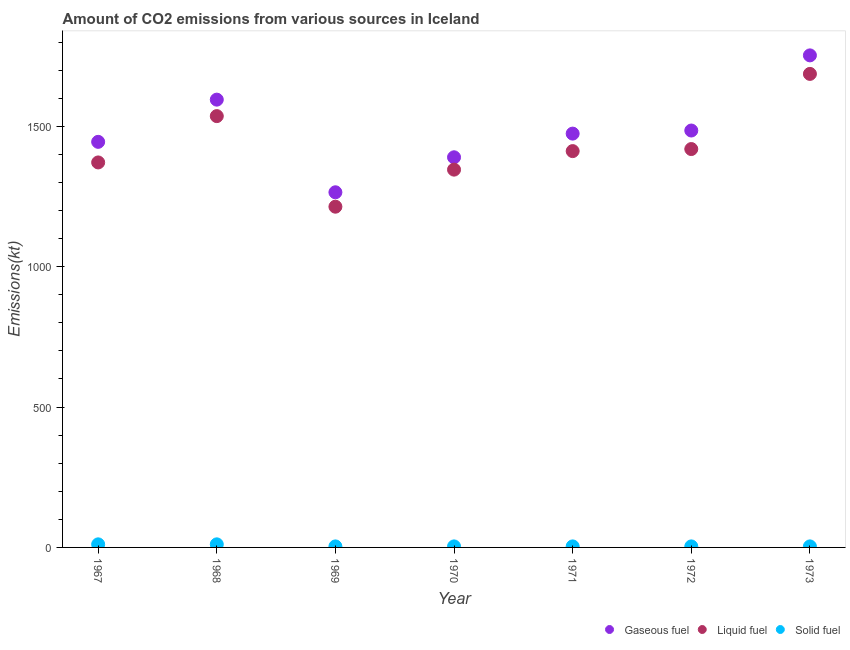What is the amount of co2 emissions from solid fuel in 1971?
Give a very brief answer. 3.67. Across all years, what is the maximum amount of co2 emissions from gaseous fuel?
Make the answer very short. 1752.83. Across all years, what is the minimum amount of co2 emissions from solid fuel?
Make the answer very short. 3.67. In which year was the amount of co2 emissions from liquid fuel minimum?
Offer a very short reply. 1969. What is the total amount of co2 emissions from gaseous fuel in the graph?
Provide a short and direct response. 1.04e+04. What is the difference between the amount of co2 emissions from liquid fuel in 1969 and the amount of co2 emissions from solid fuel in 1968?
Provide a succinct answer. 1202.78. What is the average amount of co2 emissions from gaseous fuel per year?
Give a very brief answer. 1486.71. In the year 1969, what is the difference between the amount of co2 emissions from liquid fuel and amount of co2 emissions from gaseous fuel?
Provide a succinct answer. -51.34. In how many years, is the amount of co2 emissions from gaseous fuel greater than 400 kt?
Provide a short and direct response. 7. What is the ratio of the amount of co2 emissions from gaseous fuel in 1967 to that in 1968?
Make the answer very short. 0.91. What is the difference between the highest and the lowest amount of co2 emissions from gaseous fuel?
Your answer should be very brief. 487.71. Is the amount of co2 emissions from gaseous fuel strictly greater than the amount of co2 emissions from liquid fuel over the years?
Your response must be concise. Yes. Is the amount of co2 emissions from solid fuel strictly less than the amount of co2 emissions from liquid fuel over the years?
Offer a very short reply. Yes. What is the difference between two consecutive major ticks on the Y-axis?
Give a very brief answer. 500. Does the graph contain any zero values?
Keep it short and to the point. No. Does the graph contain grids?
Give a very brief answer. No. How are the legend labels stacked?
Ensure brevity in your answer.  Horizontal. What is the title of the graph?
Give a very brief answer. Amount of CO2 emissions from various sources in Iceland. What is the label or title of the X-axis?
Provide a short and direct response. Year. What is the label or title of the Y-axis?
Your answer should be compact. Emissions(kt). What is the Emissions(kt) in Gaseous fuel in 1967?
Ensure brevity in your answer.  1444.8. What is the Emissions(kt) of Liquid fuel in 1967?
Keep it short and to the point. 1371.46. What is the Emissions(kt) of Solid fuel in 1967?
Give a very brief answer. 11. What is the Emissions(kt) of Gaseous fuel in 1968?
Your response must be concise. 1595.14. What is the Emissions(kt) of Liquid fuel in 1968?
Give a very brief answer. 1536.47. What is the Emissions(kt) of Solid fuel in 1968?
Provide a succinct answer. 11. What is the Emissions(kt) of Gaseous fuel in 1969?
Provide a succinct answer. 1265.12. What is the Emissions(kt) in Liquid fuel in 1969?
Ensure brevity in your answer.  1213.78. What is the Emissions(kt) of Solid fuel in 1969?
Offer a terse response. 3.67. What is the Emissions(kt) of Gaseous fuel in 1970?
Keep it short and to the point. 1389.79. What is the Emissions(kt) of Liquid fuel in 1970?
Keep it short and to the point. 1345.79. What is the Emissions(kt) in Solid fuel in 1970?
Give a very brief answer. 3.67. What is the Emissions(kt) in Gaseous fuel in 1971?
Your response must be concise. 1474.13. What is the Emissions(kt) in Liquid fuel in 1971?
Offer a terse response. 1411.8. What is the Emissions(kt) of Solid fuel in 1971?
Keep it short and to the point. 3.67. What is the Emissions(kt) in Gaseous fuel in 1972?
Make the answer very short. 1485.13. What is the Emissions(kt) of Liquid fuel in 1972?
Your answer should be compact. 1419.13. What is the Emissions(kt) of Solid fuel in 1972?
Offer a terse response. 3.67. What is the Emissions(kt) of Gaseous fuel in 1973?
Your response must be concise. 1752.83. What is the Emissions(kt) in Liquid fuel in 1973?
Give a very brief answer. 1686.82. What is the Emissions(kt) of Solid fuel in 1973?
Make the answer very short. 3.67. Across all years, what is the maximum Emissions(kt) of Gaseous fuel?
Offer a very short reply. 1752.83. Across all years, what is the maximum Emissions(kt) of Liquid fuel?
Give a very brief answer. 1686.82. Across all years, what is the maximum Emissions(kt) of Solid fuel?
Your answer should be compact. 11. Across all years, what is the minimum Emissions(kt) in Gaseous fuel?
Make the answer very short. 1265.12. Across all years, what is the minimum Emissions(kt) of Liquid fuel?
Offer a terse response. 1213.78. Across all years, what is the minimum Emissions(kt) in Solid fuel?
Keep it short and to the point. 3.67. What is the total Emissions(kt) in Gaseous fuel in the graph?
Ensure brevity in your answer.  1.04e+04. What is the total Emissions(kt) of Liquid fuel in the graph?
Give a very brief answer. 9985.24. What is the total Emissions(kt) of Solid fuel in the graph?
Provide a succinct answer. 40.34. What is the difference between the Emissions(kt) of Gaseous fuel in 1967 and that in 1968?
Your answer should be very brief. -150.35. What is the difference between the Emissions(kt) in Liquid fuel in 1967 and that in 1968?
Give a very brief answer. -165.01. What is the difference between the Emissions(kt) of Solid fuel in 1967 and that in 1968?
Ensure brevity in your answer.  0. What is the difference between the Emissions(kt) in Gaseous fuel in 1967 and that in 1969?
Provide a short and direct response. 179.68. What is the difference between the Emissions(kt) of Liquid fuel in 1967 and that in 1969?
Offer a very short reply. 157.68. What is the difference between the Emissions(kt) of Solid fuel in 1967 and that in 1969?
Provide a short and direct response. 7.33. What is the difference between the Emissions(kt) in Gaseous fuel in 1967 and that in 1970?
Your answer should be compact. 55.01. What is the difference between the Emissions(kt) in Liquid fuel in 1967 and that in 1970?
Offer a terse response. 25.67. What is the difference between the Emissions(kt) in Solid fuel in 1967 and that in 1970?
Keep it short and to the point. 7.33. What is the difference between the Emissions(kt) in Gaseous fuel in 1967 and that in 1971?
Offer a terse response. -29.34. What is the difference between the Emissions(kt) in Liquid fuel in 1967 and that in 1971?
Offer a terse response. -40.34. What is the difference between the Emissions(kt) in Solid fuel in 1967 and that in 1971?
Your answer should be compact. 7.33. What is the difference between the Emissions(kt) in Gaseous fuel in 1967 and that in 1972?
Provide a succinct answer. -40.34. What is the difference between the Emissions(kt) of Liquid fuel in 1967 and that in 1972?
Keep it short and to the point. -47.67. What is the difference between the Emissions(kt) of Solid fuel in 1967 and that in 1972?
Keep it short and to the point. 7.33. What is the difference between the Emissions(kt) of Gaseous fuel in 1967 and that in 1973?
Offer a very short reply. -308.03. What is the difference between the Emissions(kt) of Liquid fuel in 1967 and that in 1973?
Your answer should be compact. -315.36. What is the difference between the Emissions(kt) in Solid fuel in 1967 and that in 1973?
Your answer should be compact. 7.33. What is the difference between the Emissions(kt) in Gaseous fuel in 1968 and that in 1969?
Offer a terse response. 330.03. What is the difference between the Emissions(kt) of Liquid fuel in 1968 and that in 1969?
Offer a terse response. 322.7. What is the difference between the Emissions(kt) in Solid fuel in 1968 and that in 1969?
Your answer should be compact. 7.33. What is the difference between the Emissions(kt) in Gaseous fuel in 1968 and that in 1970?
Your answer should be very brief. 205.35. What is the difference between the Emissions(kt) in Liquid fuel in 1968 and that in 1970?
Your answer should be very brief. 190.68. What is the difference between the Emissions(kt) of Solid fuel in 1968 and that in 1970?
Provide a succinct answer. 7.33. What is the difference between the Emissions(kt) in Gaseous fuel in 1968 and that in 1971?
Your answer should be very brief. 121.01. What is the difference between the Emissions(kt) in Liquid fuel in 1968 and that in 1971?
Provide a succinct answer. 124.68. What is the difference between the Emissions(kt) in Solid fuel in 1968 and that in 1971?
Offer a terse response. 7.33. What is the difference between the Emissions(kt) in Gaseous fuel in 1968 and that in 1972?
Your answer should be compact. 110.01. What is the difference between the Emissions(kt) in Liquid fuel in 1968 and that in 1972?
Ensure brevity in your answer.  117.34. What is the difference between the Emissions(kt) in Solid fuel in 1968 and that in 1972?
Give a very brief answer. 7.33. What is the difference between the Emissions(kt) of Gaseous fuel in 1968 and that in 1973?
Your answer should be very brief. -157.68. What is the difference between the Emissions(kt) of Liquid fuel in 1968 and that in 1973?
Your response must be concise. -150.35. What is the difference between the Emissions(kt) of Solid fuel in 1968 and that in 1973?
Provide a succinct answer. 7.33. What is the difference between the Emissions(kt) of Gaseous fuel in 1969 and that in 1970?
Offer a terse response. -124.68. What is the difference between the Emissions(kt) in Liquid fuel in 1969 and that in 1970?
Make the answer very short. -132.01. What is the difference between the Emissions(kt) of Gaseous fuel in 1969 and that in 1971?
Provide a short and direct response. -209.02. What is the difference between the Emissions(kt) of Liquid fuel in 1969 and that in 1971?
Offer a very short reply. -198.02. What is the difference between the Emissions(kt) of Gaseous fuel in 1969 and that in 1972?
Offer a very short reply. -220.02. What is the difference between the Emissions(kt) of Liquid fuel in 1969 and that in 1972?
Make the answer very short. -205.35. What is the difference between the Emissions(kt) of Gaseous fuel in 1969 and that in 1973?
Your response must be concise. -487.71. What is the difference between the Emissions(kt) in Liquid fuel in 1969 and that in 1973?
Your response must be concise. -473.04. What is the difference between the Emissions(kt) in Solid fuel in 1969 and that in 1973?
Keep it short and to the point. 0. What is the difference between the Emissions(kt) in Gaseous fuel in 1970 and that in 1971?
Ensure brevity in your answer.  -84.34. What is the difference between the Emissions(kt) in Liquid fuel in 1970 and that in 1971?
Make the answer very short. -66.01. What is the difference between the Emissions(kt) in Gaseous fuel in 1970 and that in 1972?
Your response must be concise. -95.34. What is the difference between the Emissions(kt) in Liquid fuel in 1970 and that in 1972?
Ensure brevity in your answer.  -73.34. What is the difference between the Emissions(kt) of Solid fuel in 1970 and that in 1972?
Your answer should be very brief. 0. What is the difference between the Emissions(kt) of Gaseous fuel in 1970 and that in 1973?
Keep it short and to the point. -363.03. What is the difference between the Emissions(kt) in Liquid fuel in 1970 and that in 1973?
Give a very brief answer. -341.03. What is the difference between the Emissions(kt) in Gaseous fuel in 1971 and that in 1972?
Offer a very short reply. -11. What is the difference between the Emissions(kt) of Liquid fuel in 1971 and that in 1972?
Keep it short and to the point. -7.33. What is the difference between the Emissions(kt) of Gaseous fuel in 1971 and that in 1973?
Offer a very short reply. -278.69. What is the difference between the Emissions(kt) in Liquid fuel in 1971 and that in 1973?
Make the answer very short. -275.02. What is the difference between the Emissions(kt) of Solid fuel in 1971 and that in 1973?
Keep it short and to the point. 0. What is the difference between the Emissions(kt) of Gaseous fuel in 1972 and that in 1973?
Offer a very short reply. -267.69. What is the difference between the Emissions(kt) in Liquid fuel in 1972 and that in 1973?
Offer a very short reply. -267.69. What is the difference between the Emissions(kt) in Gaseous fuel in 1967 and the Emissions(kt) in Liquid fuel in 1968?
Make the answer very short. -91.67. What is the difference between the Emissions(kt) of Gaseous fuel in 1967 and the Emissions(kt) of Solid fuel in 1968?
Provide a short and direct response. 1433.8. What is the difference between the Emissions(kt) in Liquid fuel in 1967 and the Emissions(kt) in Solid fuel in 1968?
Your answer should be compact. 1360.46. What is the difference between the Emissions(kt) in Gaseous fuel in 1967 and the Emissions(kt) in Liquid fuel in 1969?
Provide a short and direct response. 231.02. What is the difference between the Emissions(kt) in Gaseous fuel in 1967 and the Emissions(kt) in Solid fuel in 1969?
Your answer should be very brief. 1441.13. What is the difference between the Emissions(kt) in Liquid fuel in 1967 and the Emissions(kt) in Solid fuel in 1969?
Your response must be concise. 1367.79. What is the difference between the Emissions(kt) in Gaseous fuel in 1967 and the Emissions(kt) in Liquid fuel in 1970?
Your answer should be very brief. 99.01. What is the difference between the Emissions(kt) of Gaseous fuel in 1967 and the Emissions(kt) of Solid fuel in 1970?
Provide a succinct answer. 1441.13. What is the difference between the Emissions(kt) in Liquid fuel in 1967 and the Emissions(kt) in Solid fuel in 1970?
Offer a terse response. 1367.79. What is the difference between the Emissions(kt) of Gaseous fuel in 1967 and the Emissions(kt) of Liquid fuel in 1971?
Provide a succinct answer. 33. What is the difference between the Emissions(kt) of Gaseous fuel in 1967 and the Emissions(kt) of Solid fuel in 1971?
Ensure brevity in your answer.  1441.13. What is the difference between the Emissions(kt) of Liquid fuel in 1967 and the Emissions(kt) of Solid fuel in 1971?
Your answer should be very brief. 1367.79. What is the difference between the Emissions(kt) of Gaseous fuel in 1967 and the Emissions(kt) of Liquid fuel in 1972?
Provide a short and direct response. 25.67. What is the difference between the Emissions(kt) of Gaseous fuel in 1967 and the Emissions(kt) of Solid fuel in 1972?
Keep it short and to the point. 1441.13. What is the difference between the Emissions(kt) of Liquid fuel in 1967 and the Emissions(kt) of Solid fuel in 1972?
Offer a very short reply. 1367.79. What is the difference between the Emissions(kt) in Gaseous fuel in 1967 and the Emissions(kt) in Liquid fuel in 1973?
Make the answer very short. -242.02. What is the difference between the Emissions(kt) of Gaseous fuel in 1967 and the Emissions(kt) of Solid fuel in 1973?
Your answer should be very brief. 1441.13. What is the difference between the Emissions(kt) of Liquid fuel in 1967 and the Emissions(kt) of Solid fuel in 1973?
Make the answer very short. 1367.79. What is the difference between the Emissions(kt) in Gaseous fuel in 1968 and the Emissions(kt) in Liquid fuel in 1969?
Provide a short and direct response. 381.37. What is the difference between the Emissions(kt) in Gaseous fuel in 1968 and the Emissions(kt) in Solid fuel in 1969?
Make the answer very short. 1591.48. What is the difference between the Emissions(kt) of Liquid fuel in 1968 and the Emissions(kt) of Solid fuel in 1969?
Keep it short and to the point. 1532.81. What is the difference between the Emissions(kt) of Gaseous fuel in 1968 and the Emissions(kt) of Liquid fuel in 1970?
Your answer should be compact. 249.36. What is the difference between the Emissions(kt) of Gaseous fuel in 1968 and the Emissions(kt) of Solid fuel in 1970?
Ensure brevity in your answer.  1591.48. What is the difference between the Emissions(kt) in Liquid fuel in 1968 and the Emissions(kt) in Solid fuel in 1970?
Your response must be concise. 1532.81. What is the difference between the Emissions(kt) in Gaseous fuel in 1968 and the Emissions(kt) in Liquid fuel in 1971?
Your response must be concise. 183.35. What is the difference between the Emissions(kt) of Gaseous fuel in 1968 and the Emissions(kt) of Solid fuel in 1971?
Offer a very short reply. 1591.48. What is the difference between the Emissions(kt) in Liquid fuel in 1968 and the Emissions(kt) in Solid fuel in 1971?
Keep it short and to the point. 1532.81. What is the difference between the Emissions(kt) of Gaseous fuel in 1968 and the Emissions(kt) of Liquid fuel in 1972?
Your answer should be compact. 176.02. What is the difference between the Emissions(kt) in Gaseous fuel in 1968 and the Emissions(kt) in Solid fuel in 1972?
Offer a terse response. 1591.48. What is the difference between the Emissions(kt) of Liquid fuel in 1968 and the Emissions(kt) of Solid fuel in 1972?
Keep it short and to the point. 1532.81. What is the difference between the Emissions(kt) of Gaseous fuel in 1968 and the Emissions(kt) of Liquid fuel in 1973?
Your answer should be compact. -91.67. What is the difference between the Emissions(kt) of Gaseous fuel in 1968 and the Emissions(kt) of Solid fuel in 1973?
Make the answer very short. 1591.48. What is the difference between the Emissions(kt) of Liquid fuel in 1968 and the Emissions(kt) of Solid fuel in 1973?
Your answer should be compact. 1532.81. What is the difference between the Emissions(kt) in Gaseous fuel in 1969 and the Emissions(kt) in Liquid fuel in 1970?
Offer a very short reply. -80.67. What is the difference between the Emissions(kt) of Gaseous fuel in 1969 and the Emissions(kt) of Solid fuel in 1970?
Offer a terse response. 1261.45. What is the difference between the Emissions(kt) in Liquid fuel in 1969 and the Emissions(kt) in Solid fuel in 1970?
Offer a very short reply. 1210.11. What is the difference between the Emissions(kt) of Gaseous fuel in 1969 and the Emissions(kt) of Liquid fuel in 1971?
Provide a succinct answer. -146.68. What is the difference between the Emissions(kt) of Gaseous fuel in 1969 and the Emissions(kt) of Solid fuel in 1971?
Provide a short and direct response. 1261.45. What is the difference between the Emissions(kt) in Liquid fuel in 1969 and the Emissions(kt) in Solid fuel in 1971?
Offer a very short reply. 1210.11. What is the difference between the Emissions(kt) in Gaseous fuel in 1969 and the Emissions(kt) in Liquid fuel in 1972?
Your response must be concise. -154.01. What is the difference between the Emissions(kt) in Gaseous fuel in 1969 and the Emissions(kt) in Solid fuel in 1972?
Give a very brief answer. 1261.45. What is the difference between the Emissions(kt) of Liquid fuel in 1969 and the Emissions(kt) of Solid fuel in 1972?
Your answer should be compact. 1210.11. What is the difference between the Emissions(kt) of Gaseous fuel in 1969 and the Emissions(kt) of Liquid fuel in 1973?
Your answer should be compact. -421.7. What is the difference between the Emissions(kt) of Gaseous fuel in 1969 and the Emissions(kt) of Solid fuel in 1973?
Offer a terse response. 1261.45. What is the difference between the Emissions(kt) of Liquid fuel in 1969 and the Emissions(kt) of Solid fuel in 1973?
Make the answer very short. 1210.11. What is the difference between the Emissions(kt) in Gaseous fuel in 1970 and the Emissions(kt) in Liquid fuel in 1971?
Your answer should be very brief. -22. What is the difference between the Emissions(kt) in Gaseous fuel in 1970 and the Emissions(kt) in Solid fuel in 1971?
Offer a terse response. 1386.13. What is the difference between the Emissions(kt) in Liquid fuel in 1970 and the Emissions(kt) in Solid fuel in 1971?
Your answer should be very brief. 1342.12. What is the difference between the Emissions(kt) of Gaseous fuel in 1970 and the Emissions(kt) of Liquid fuel in 1972?
Your answer should be very brief. -29.34. What is the difference between the Emissions(kt) of Gaseous fuel in 1970 and the Emissions(kt) of Solid fuel in 1972?
Ensure brevity in your answer.  1386.13. What is the difference between the Emissions(kt) of Liquid fuel in 1970 and the Emissions(kt) of Solid fuel in 1972?
Your answer should be compact. 1342.12. What is the difference between the Emissions(kt) in Gaseous fuel in 1970 and the Emissions(kt) in Liquid fuel in 1973?
Make the answer very short. -297.03. What is the difference between the Emissions(kt) in Gaseous fuel in 1970 and the Emissions(kt) in Solid fuel in 1973?
Make the answer very short. 1386.13. What is the difference between the Emissions(kt) of Liquid fuel in 1970 and the Emissions(kt) of Solid fuel in 1973?
Make the answer very short. 1342.12. What is the difference between the Emissions(kt) of Gaseous fuel in 1971 and the Emissions(kt) of Liquid fuel in 1972?
Offer a terse response. 55.01. What is the difference between the Emissions(kt) in Gaseous fuel in 1971 and the Emissions(kt) in Solid fuel in 1972?
Provide a short and direct response. 1470.47. What is the difference between the Emissions(kt) in Liquid fuel in 1971 and the Emissions(kt) in Solid fuel in 1972?
Your answer should be very brief. 1408.13. What is the difference between the Emissions(kt) of Gaseous fuel in 1971 and the Emissions(kt) of Liquid fuel in 1973?
Offer a terse response. -212.69. What is the difference between the Emissions(kt) in Gaseous fuel in 1971 and the Emissions(kt) in Solid fuel in 1973?
Your answer should be very brief. 1470.47. What is the difference between the Emissions(kt) in Liquid fuel in 1971 and the Emissions(kt) in Solid fuel in 1973?
Provide a succinct answer. 1408.13. What is the difference between the Emissions(kt) of Gaseous fuel in 1972 and the Emissions(kt) of Liquid fuel in 1973?
Your response must be concise. -201.69. What is the difference between the Emissions(kt) in Gaseous fuel in 1972 and the Emissions(kt) in Solid fuel in 1973?
Make the answer very short. 1481.47. What is the difference between the Emissions(kt) in Liquid fuel in 1972 and the Emissions(kt) in Solid fuel in 1973?
Your answer should be compact. 1415.46. What is the average Emissions(kt) in Gaseous fuel per year?
Ensure brevity in your answer.  1486.71. What is the average Emissions(kt) in Liquid fuel per year?
Your answer should be very brief. 1426.46. What is the average Emissions(kt) in Solid fuel per year?
Your answer should be very brief. 5.76. In the year 1967, what is the difference between the Emissions(kt) in Gaseous fuel and Emissions(kt) in Liquid fuel?
Offer a terse response. 73.34. In the year 1967, what is the difference between the Emissions(kt) in Gaseous fuel and Emissions(kt) in Solid fuel?
Your response must be concise. 1433.8. In the year 1967, what is the difference between the Emissions(kt) in Liquid fuel and Emissions(kt) in Solid fuel?
Give a very brief answer. 1360.46. In the year 1968, what is the difference between the Emissions(kt) in Gaseous fuel and Emissions(kt) in Liquid fuel?
Keep it short and to the point. 58.67. In the year 1968, what is the difference between the Emissions(kt) in Gaseous fuel and Emissions(kt) in Solid fuel?
Ensure brevity in your answer.  1584.14. In the year 1968, what is the difference between the Emissions(kt) in Liquid fuel and Emissions(kt) in Solid fuel?
Make the answer very short. 1525.47. In the year 1969, what is the difference between the Emissions(kt) of Gaseous fuel and Emissions(kt) of Liquid fuel?
Your response must be concise. 51.34. In the year 1969, what is the difference between the Emissions(kt) in Gaseous fuel and Emissions(kt) in Solid fuel?
Give a very brief answer. 1261.45. In the year 1969, what is the difference between the Emissions(kt) in Liquid fuel and Emissions(kt) in Solid fuel?
Provide a succinct answer. 1210.11. In the year 1970, what is the difference between the Emissions(kt) of Gaseous fuel and Emissions(kt) of Liquid fuel?
Ensure brevity in your answer.  44. In the year 1970, what is the difference between the Emissions(kt) of Gaseous fuel and Emissions(kt) of Solid fuel?
Provide a short and direct response. 1386.13. In the year 1970, what is the difference between the Emissions(kt) of Liquid fuel and Emissions(kt) of Solid fuel?
Your answer should be very brief. 1342.12. In the year 1971, what is the difference between the Emissions(kt) in Gaseous fuel and Emissions(kt) in Liquid fuel?
Your response must be concise. 62.34. In the year 1971, what is the difference between the Emissions(kt) of Gaseous fuel and Emissions(kt) of Solid fuel?
Make the answer very short. 1470.47. In the year 1971, what is the difference between the Emissions(kt) in Liquid fuel and Emissions(kt) in Solid fuel?
Give a very brief answer. 1408.13. In the year 1972, what is the difference between the Emissions(kt) of Gaseous fuel and Emissions(kt) of Liquid fuel?
Provide a succinct answer. 66.01. In the year 1972, what is the difference between the Emissions(kt) in Gaseous fuel and Emissions(kt) in Solid fuel?
Your response must be concise. 1481.47. In the year 1972, what is the difference between the Emissions(kt) in Liquid fuel and Emissions(kt) in Solid fuel?
Your answer should be compact. 1415.46. In the year 1973, what is the difference between the Emissions(kt) in Gaseous fuel and Emissions(kt) in Liquid fuel?
Keep it short and to the point. 66.01. In the year 1973, what is the difference between the Emissions(kt) of Gaseous fuel and Emissions(kt) of Solid fuel?
Offer a terse response. 1749.16. In the year 1973, what is the difference between the Emissions(kt) in Liquid fuel and Emissions(kt) in Solid fuel?
Your answer should be compact. 1683.15. What is the ratio of the Emissions(kt) in Gaseous fuel in 1967 to that in 1968?
Give a very brief answer. 0.91. What is the ratio of the Emissions(kt) in Liquid fuel in 1967 to that in 1968?
Keep it short and to the point. 0.89. What is the ratio of the Emissions(kt) of Solid fuel in 1967 to that in 1968?
Make the answer very short. 1. What is the ratio of the Emissions(kt) of Gaseous fuel in 1967 to that in 1969?
Make the answer very short. 1.14. What is the ratio of the Emissions(kt) of Liquid fuel in 1967 to that in 1969?
Provide a short and direct response. 1.13. What is the ratio of the Emissions(kt) of Solid fuel in 1967 to that in 1969?
Your response must be concise. 3. What is the ratio of the Emissions(kt) of Gaseous fuel in 1967 to that in 1970?
Make the answer very short. 1.04. What is the ratio of the Emissions(kt) in Liquid fuel in 1967 to that in 1970?
Your answer should be very brief. 1.02. What is the ratio of the Emissions(kt) of Solid fuel in 1967 to that in 1970?
Provide a short and direct response. 3. What is the ratio of the Emissions(kt) in Gaseous fuel in 1967 to that in 1971?
Provide a succinct answer. 0.98. What is the ratio of the Emissions(kt) in Liquid fuel in 1967 to that in 1971?
Ensure brevity in your answer.  0.97. What is the ratio of the Emissions(kt) of Gaseous fuel in 1967 to that in 1972?
Provide a short and direct response. 0.97. What is the ratio of the Emissions(kt) in Liquid fuel in 1967 to that in 1972?
Provide a short and direct response. 0.97. What is the ratio of the Emissions(kt) of Gaseous fuel in 1967 to that in 1973?
Offer a very short reply. 0.82. What is the ratio of the Emissions(kt) of Liquid fuel in 1967 to that in 1973?
Give a very brief answer. 0.81. What is the ratio of the Emissions(kt) of Gaseous fuel in 1968 to that in 1969?
Your response must be concise. 1.26. What is the ratio of the Emissions(kt) of Liquid fuel in 1968 to that in 1969?
Your response must be concise. 1.27. What is the ratio of the Emissions(kt) of Solid fuel in 1968 to that in 1969?
Make the answer very short. 3. What is the ratio of the Emissions(kt) of Gaseous fuel in 1968 to that in 1970?
Offer a very short reply. 1.15. What is the ratio of the Emissions(kt) of Liquid fuel in 1968 to that in 1970?
Keep it short and to the point. 1.14. What is the ratio of the Emissions(kt) of Solid fuel in 1968 to that in 1970?
Provide a succinct answer. 3. What is the ratio of the Emissions(kt) in Gaseous fuel in 1968 to that in 1971?
Your answer should be very brief. 1.08. What is the ratio of the Emissions(kt) in Liquid fuel in 1968 to that in 1971?
Ensure brevity in your answer.  1.09. What is the ratio of the Emissions(kt) in Gaseous fuel in 1968 to that in 1972?
Ensure brevity in your answer.  1.07. What is the ratio of the Emissions(kt) in Liquid fuel in 1968 to that in 1972?
Make the answer very short. 1.08. What is the ratio of the Emissions(kt) of Gaseous fuel in 1968 to that in 1973?
Make the answer very short. 0.91. What is the ratio of the Emissions(kt) of Liquid fuel in 1968 to that in 1973?
Provide a succinct answer. 0.91. What is the ratio of the Emissions(kt) in Solid fuel in 1968 to that in 1973?
Give a very brief answer. 3. What is the ratio of the Emissions(kt) of Gaseous fuel in 1969 to that in 1970?
Give a very brief answer. 0.91. What is the ratio of the Emissions(kt) in Liquid fuel in 1969 to that in 1970?
Make the answer very short. 0.9. What is the ratio of the Emissions(kt) of Solid fuel in 1969 to that in 1970?
Give a very brief answer. 1. What is the ratio of the Emissions(kt) in Gaseous fuel in 1969 to that in 1971?
Your answer should be very brief. 0.86. What is the ratio of the Emissions(kt) of Liquid fuel in 1969 to that in 1971?
Keep it short and to the point. 0.86. What is the ratio of the Emissions(kt) in Solid fuel in 1969 to that in 1971?
Ensure brevity in your answer.  1. What is the ratio of the Emissions(kt) in Gaseous fuel in 1969 to that in 1972?
Provide a short and direct response. 0.85. What is the ratio of the Emissions(kt) in Liquid fuel in 1969 to that in 1972?
Keep it short and to the point. 0.86. What is the ratio of the Emissions(kt) in Solid fuel in 1969 to that in 1972?
Provide a short and direct response. 1. What is the ratio of the Emissions(kt) of Gaseous fuel in 1969 to that in 1973?
Offer a terse response. 0.72. What is the ratio of the Emissions(kt) in Liquid fuel in 1969 to that in 1973?
Your response must be concise. 0.72. What is the ratio of the Emissions(kt) of Gaseous fuel in 1970 to that in 1971?
Ensure brevity in your answer.  0.94. What is the ratio of the Emissions(kt) of Liquid fuel in 1970 to that in 1971?
Offer a terse response. 0.95. What is the ratio of the Emissions(kt) of Solid fuel in 1970 to that in 1971?
Provide a succinct answer. 1. What is the ratio of the Emissions(kt) in Gaseous fuel in 1970 to that in 1972?
Make the answer very short. 0.94. What is the ratio of the Emissions(kt) of Liquid fuel in 1970 to that in 1972?
Offer a very short reply. 0.95. What is the ratio of the Emissions(kt) of Solid fuel in 1970 to that in 1972?
Provide a short and direct response. 1. What is the ratio of the Emissions(kt) in Gaseous fuel in 1970 to that in 1973?
Your answer should be compact. 0.79. What is the ratio of the Emissions(kt) in Liquid fuel in 1970 to that in 1973?
Offer a terse response. 0.8. What is the ratio of the Emissions(kt) of Solid fuel in 1970 to that in 1973?
Offer a very short reply. 1. What is the ratio of the Emissions(kt) in Gaseous fuel in 1971 to that in 1972?
Offer a very short reply. 0.99. What is the ratio of the Emissions(kt) of Solid fuel in 1971 to that in 1972?
Keep it short and to the point. 1. What is the ratio of the Emissions(kt) in Gaseous fuel in 1971 to that in 1973?
Offer a terse response. 0.84. What is the ratio of the Emissions(kt) in Liquid fuel in 1971 to that in 1973?
Provide a succinct answer. 0.84. What is the ratio of the Emissions(kt) in Solid fuel in 1971 to that in 1973?
Your answer should be very brief. 1. What is the ratio of the Emissions(kt) in Gaseous fuel in 1972 to that in 1973?
Provide a short and direct response. 0.85. What is the ratio of the Emissions(kt) of Liquid fuel in 1972 to that in 1973?
Your answer should be very brief. 0.84. What is the ratio of the Emissions(kt) in Solid fuel in 1972 to that in 1973?
Your response must be concise. 1. What is the difference between the highest and the second highest Emissions(kt) of Gaseous fuel?
Offer a terse response. 157.68. What is the difference between the highest and the second highest Emissions(kt) in Liquid fuel?
Give a very brief answer. 150.35. What is the difference between the highest and the lowest Emissions(kt) in Gaseous fuel?
Offer a terse response. 487.71. What is the difference between the highest and the lowest Emissions(kt) in Liquid fuel?
Provide a short and direct response. 473.04. What is the difference between the highest and the lowest Emissions(kt) in Solid fuel?
Offer a very short reply. 7.33. 